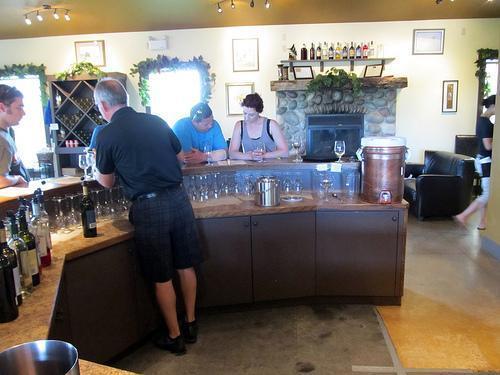How many men are visible?
Give a very brief answer. 3. How many women are visible?
Give a very brief answer. 2. 